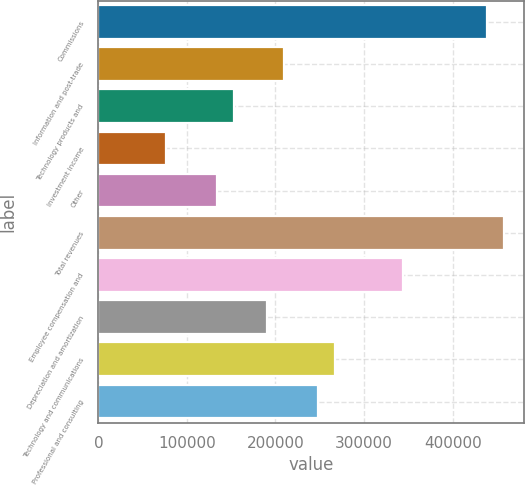Convert chart. <chart><loc_0><loc_0><loc_500><loc_500><bar_chart><fcel>Commissions<fcel>Information and post-trade<fcel>Technology products and<fcel>Investment income<fcel>Other<fcel>Total revenues<fcel>Employee compensation and<fcel>Depreciation and amortization<fcel>Technology and communications<fcel>Professional and consulting<nl><fcel>438932<fcel>209924<fcel>152672<fcel>76336<fcel>133588<fcel>458016<fcel>343512<fcel>190840<fcel>267176<fcel>248092<nl></chart> 